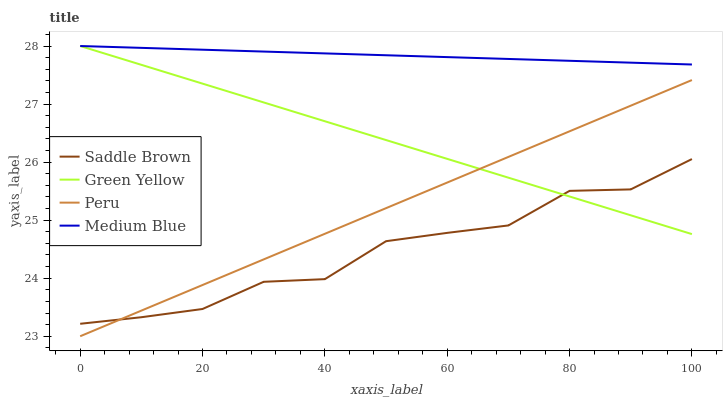Does Saddle Brown have the minimum area under the curve?
Answer yes or no. Yes. Does Medium Blue have the maximum area under the curve?
Answer yes or no. Yes. Does Medium Blue have the minimum area under the curve?
Answer yes or no. No. Does Saddle Brown have the maximum area under the curve?
Answer yes or no. No. Is Medium Blue the smoothest?
Answer yes or no. Yes. Is Saddle Brown the roughest?
Answer yes or no. Yes. Is Saddle Brown the smoothest?
Answer yes or no. No. Is Medium Blue the roughest?
Answer yes or no. No. Does Peru have the lowest value?
Answer yes or no. Yes. Does Saddle Brown have the lowest value?
Answer yes or no. No. Does Medium Blue have the highest value?
Answer yes or no. Yes. Does Saddle Brown have the highest value?
Answer yes or no. No. Is Saddle Brown less than Medium Blue?
Answer yes or no. Yes. Is Medium Blue greater than Peru?
Answer yes or no. Yes. Does Medium Blue intersect Green Yellow?
Answer yes or no. Yes. Is Medium Blue less than Green Yellow?
Answer yes or no. No. Is Medium Blue greater than Green Yellow?
Answer yes or no. No. Does Saddle Brown intersect Medium Blue?
Answer yes or no. No. 